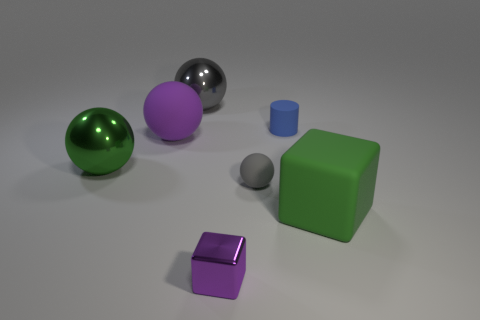Is the number of large green objects less than the number of small rubber spheres?
Keep it short and to the point. No. What is the shape of the small gray matte thing?
Keep it short and to the point. Sphere. Does the large thing that is on the left side of the purple matte thing have the same color as the matte cylinder?
Ensure brevity in your answer.  No. What shape is the thing that is to the left of the tiny sphere and behind the purple sphere?
Provide a short and direct response. Sphere. There is a metal thing behind the tiny matte cylinder; what color is it?
Provide a succinct answer. Gray. Is there anything else of the same color as the tiny ball?
Give a very brief answer. Yes. Does the blue rubber object have the same size as the purple metallic object?
Your answer should be very brief. Yes. What size is the shiny thing that is both behind the purple cube and on the right side of the green metallic thing?
Ensure brevity in your answer.  Large. How many other large spheres have the same material as the large purple sphere?
Your answer should be compact. 0. What shape is the big rubber thing that is the same color as the tiny cube?
Make the answer very short. Sphere. 